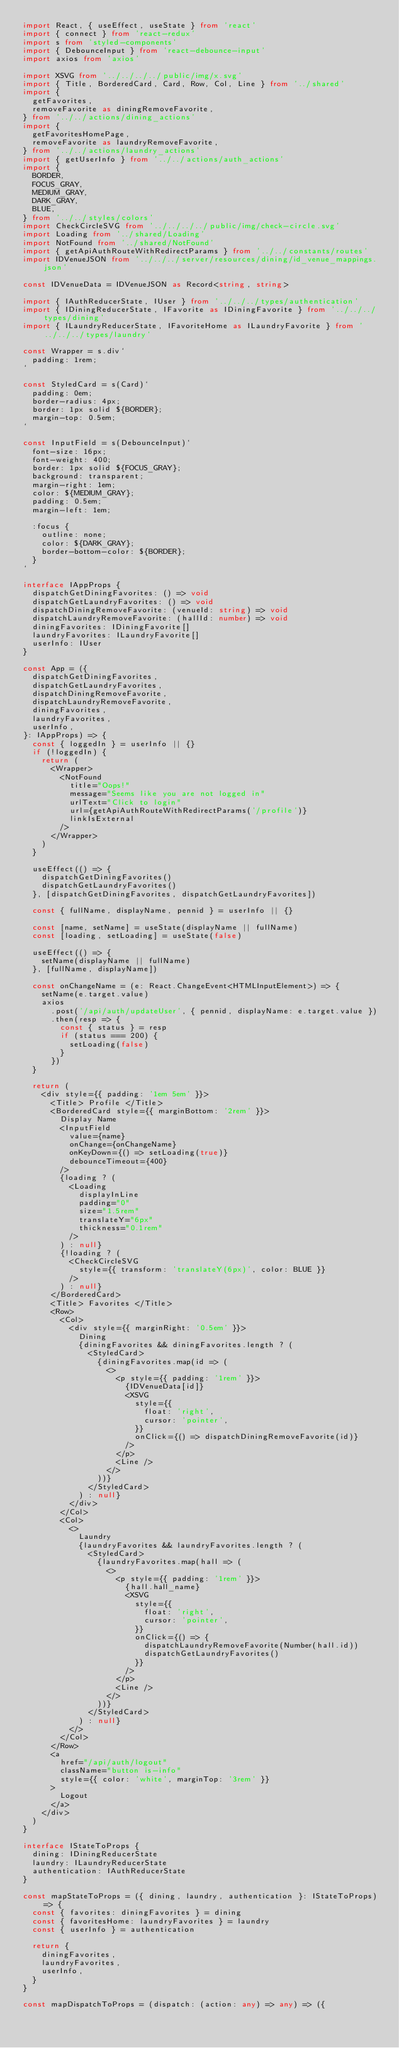Convert code to text. <code><loc_0><loc_0><loc_500><loc_500><_TypeScript_>import React, { useEffect, useState } from 'react'
import { connect } from 'react-redux'
import s from 'styled-components'
import { DebounceInput } from 'react-debounce-input'
import axios from 'axios'

import XSVG from '../../../../public/img/x.svg'
import { Title, BorderedCard, Card, Row, Col, Line } from '../shared'
import {
  getFavorites,
  removeFavorite as diningRemoveFavorite,
} from '../../actions/dining_actions'
import {
  getFavoritesHomePage,
  removeFavorite as laundryRemoveFavorite,
} from '../../actions/laundry_actions'
import { getUserInfo } from '../../actions/auth_actions'
import {
  BORDER,
  FOCUS_GRAY,
  MEDIUM_GRAY,
  DARK_GRAY,
  BLUE,
} from '../../styles/colors'
import CheckCircleSVG from '../../../../public/img/check-circle.svg'
import Loading from '../shared/Loading'
import NotFound from '../shared/NotFound'
import { getApiAuthRouteWithRedirectParams } from '../../constants/routes'
import IDVenueJSON from '../../../server/resources/dining/id_venue_mappings.json'

const IDVenueData = IDVenueJSON as Record<string, string>

import { IAuthReducerState, IUser } from '../../../types/authentication'
import { IDiningReducerState, IFavorite as IDiningFavorite } from '../../../types/dining'
import { ILaundryReducerState, IFavoriteHome as ILaundryFavorite } from '../../../types/laundry'

const Wrapper = s.div`
  padding: 1rem;
`

const StyledCard = s(Card)`
  padding: 0em;
  border-radius: 4px;
  border: 1px solid ${BORDER};
  margin-top: 0.5em;
`

const InputField = s(DebounceInput)`
  font-size: 16px;
  font-weight: 400;
  border: 1px solid ${FOCUS_GRAY};
  background: transparent;
  margin-right: 1em;
  color: ${MEDIUM_GRAY};
  padding: 0.5em;
  margin-left: 1em;
  
  :focus {
    outline: none;
    color: ${DARK_GRAY};
    border-bottom-color: ${BORDER};
  }
`

interface IAppProps {
  dispatchGetDiningFavorites: () => void
  dispatchGetLaundryFavorites: () => void
  dispatchDiningRemoveFavorite: (venueId: string) => void
  dispatchLaundryRemoveFavorite: (hallId: number) => void
  diningFavorites: IDiningFavorite[]
  laundryFavorites: ILaundryFavorite[]
  userInfo: IUser
}

const App = ({
  dispatchGetDiningFavorites,
  dispatchGetLaundryFavorites,
  dispatchDiningRemoveFavorite,
  dispatchLaundryRemoveFavorite,
  diningFavorites,
  laundryFavorites,
  userInfo,
}: IAppProps) => {
  const { loggedIn } = userInfo || {}
  if (!loggedIn) {
    return (
      <Wrapper>
        <NotFound
          title="Oops!"
          message="Seems like you are not logged in"
          urlText="Click to login"
          url={getApiAuthRouteWithRedirectParams('/profile')}
          linkIsExternal
        />
      </Wrapper>
    )
  }

  useEffect(() => {
    dispatchGetDiningFavorites()
    dispatchGetLaundryFavorites()
  }, [dispatchGetDiningFavorites, dispatchGetLaundryFavorites])

  const { fullName, displayName, pennid } = userInfo || {}

  const [name, setName] = useState(displayName || fullName)
  const [loading, setLoading] = useState(false)

  useEffect(() => {
    setName(displayName || fullName)
  }, [fullName, displayName])

  const onChangeName = (e: React.ChangeEvent<HTMLInputElement>) => {
    setName(e.target.value)
    axios
      .post('/api/auth/updateUser', { pennid, displayName: e.target.value })
      .then(resp => {
        const { status } = resp
        if (status === 200) {
          setLoading(false)
        }
      })
  }

  return (
    <div style={{ padding: '1em 5em' }}>
      <Title> Profile </Title>
      <BorderedCard style={{ marginBottom: '2rem' }}>
        Display Name
        <InputField
          value={name}
          onChange={onChangeName}
          onKeyDown={() => setLoading(true)}
          debounceTimeout={400}
        />
        {loading ? (
          <Loading
            displayInLine
            padding="0"
            size="1.5rem"
            translateY="6px"
            thickness="0.1rem"
          />
        ) : null}
        {!loading ? (
          <CheckCircleSVG
            style={{ transform: 'translateY(6px)', color: BLUE }}
          />
        ) : null}
      </BorderedCard>
      <Title> Favorites </Title>
      <Row>
        <Col>
          <div style={{ marginRight: '0.5em' }}>
            Dining
            {diningFavorites && diningFavorites.length ? (
              <StyledCard>
                {diningFavorites.map(id => (
                  <>
                    <p style={{ padding: '1rem' }}>
                      {IDVenueData[id]}
                      <XSVG
                        style={{
                          float: 'right',
                          cursor: 'pointer',
                        }}
                        onClick={() => dispatchDiningRemoveFavorite(id)}
                      />
                    </p>
                    <Line />
                  </>
                ))}
              </StyledCard>
            ) : null}
          </div>
        </Col>
        <Col>
          <>
            Laundry
            {laundryFavorites && laundryFavorites.length ? (
              <StyledCard>
                {laundryFavorites.map(hall => (
                  <>
                    <p style={{ padding: '1rem' }}>
                      {hall.hall_name}
                      <XSVG
                        style={{
                          float: 'right',
                          cursor: 'pointer',
                        }}
                        onClick={() => {
                          dispatchLaundryRemoveFavorite(Number(hall.id))
                          dispatchGetLaundryFavorites()
                        }}
                      />
                    </p>
                    <Line />
                  </>
                ))}
              </StyledCard>
            ) : null}
          </>
        </Col>
      </Row>
      <a
        href="/api/auth/logout"
        className="button is-info"
        style={{ color: 'white', marginTop: '3rem' }}
      >
        Logout
      </a>
    </div>
  )
}

interface IStateToProps {
  dining: IDiningReducerState
  laundry: ILaundryReducerState
  authentication: IAuthReducerState
}

const mapStateToProps = ({ dining, laundry, authentication }: IStateToProps) => {
  const { favorites: diningFavorites } = dining
  const { favoritesHome: laundryFavorites } = laundry
  const { userInfo } = authentication

  return {
    diningFavorites,
    laundryFavorites,
    userInfo,
  }
}

const mapDispatchToProps = (dispatch: (action: any) => any) => ({</code> 